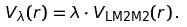Convert formula to latex. <formula><loc_0><loc_0><loc_500><loc_500>V _ { \lambda } ( r ) = \lambda \cdot V _ { \text {LM2M2} } ( r ) \, .</formula> 